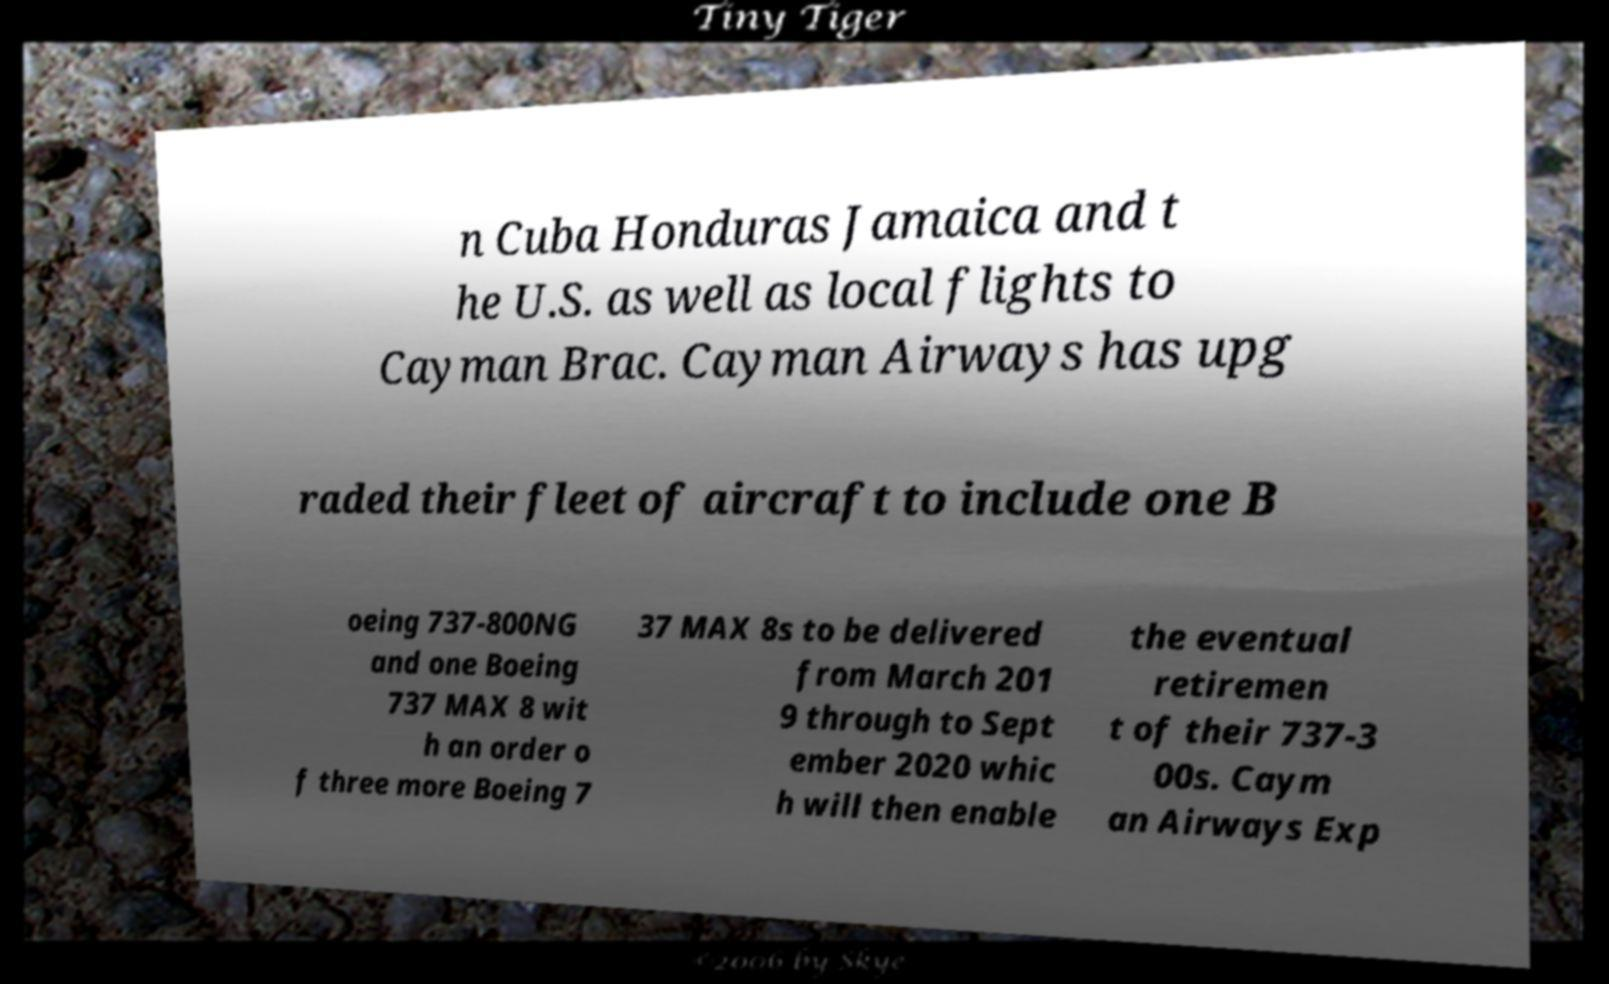Please identify and transcribe the text found in this image. n Cuba Honduras Jamaica and t he U.S. as well as local flights to Cayman Brac. Cayman Airways has upg raded their fleet of aircraft to include one B oeing 737-800NG and one Boeing 737 MAX 8 wit h an order o f three more Boeing 7 37 MAX 8s to be delivered from March 201 9 through to Sept ember 2020 whic h will then enable the eventual retiremen t of their 737-3 00s. Caym an Airways Exp 